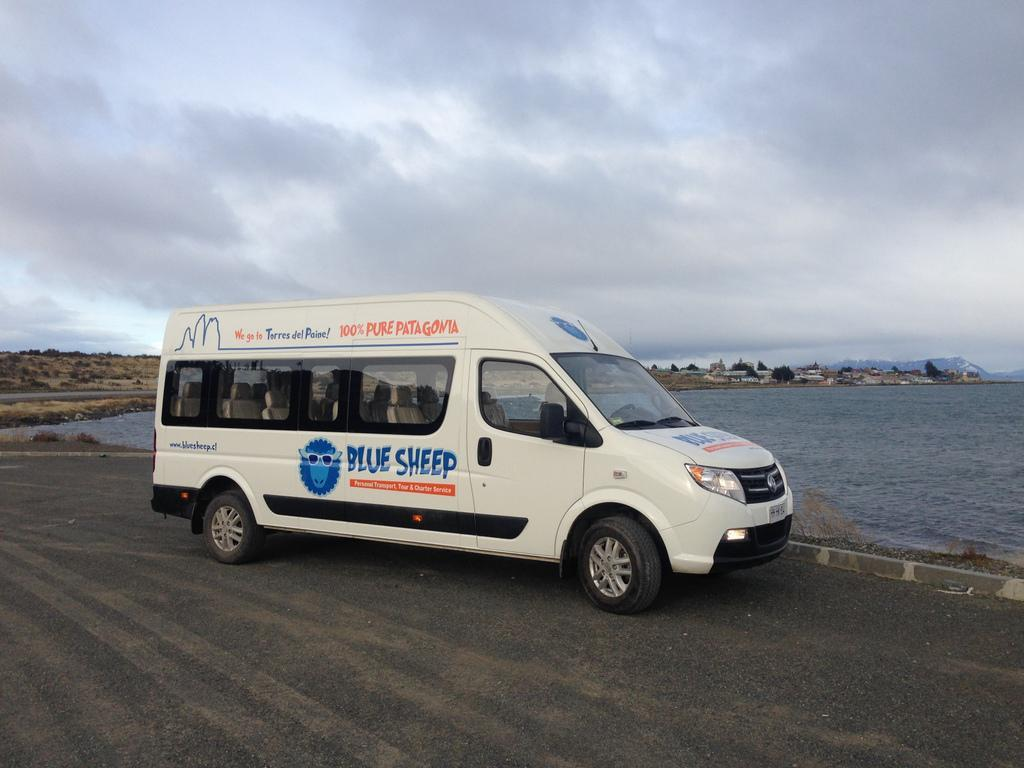<image>
Summarize the visual content of the image. a blue sheep van that is next to the water 